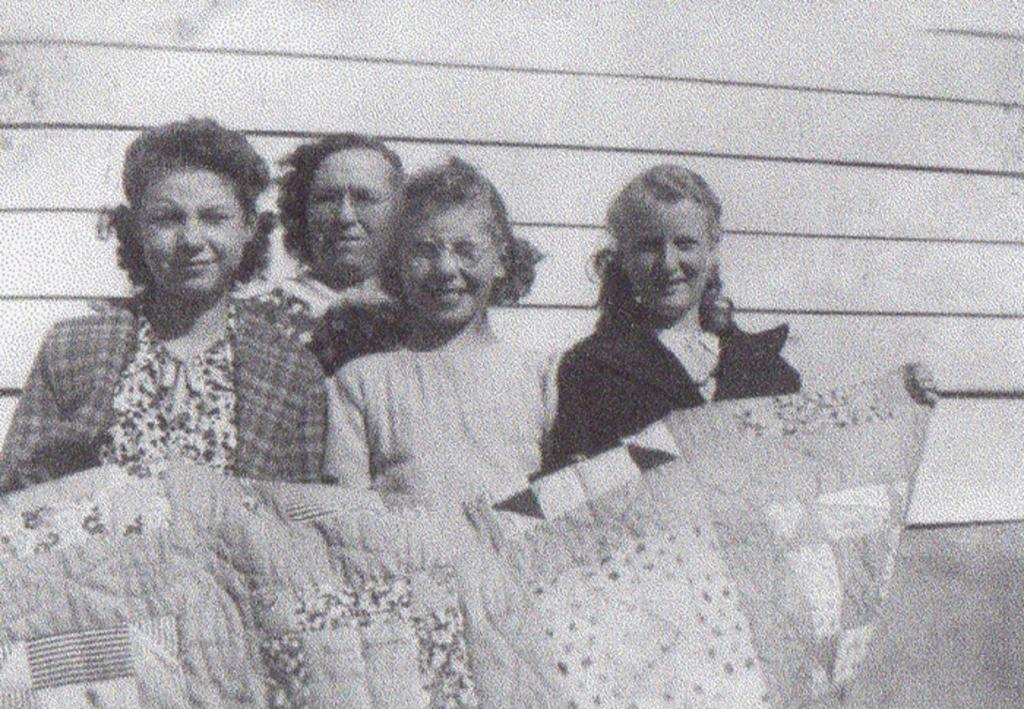What is the color scheme of the image? The image is black and white. How many people are present in the image? There are four people in the image. What are the people holding in the image? The people are holding a blanket. What can be seen in the background of the image? There is a wall visible in the background of the image. What type of pets are sitting on the boundary in the image? There are no pets or boundaries present in the image; it features four people holding a blanket. How many thumbs can be seen on the people in the image? The image is black and white, so it is impossible to determine the number of thumbs visible on the people. 